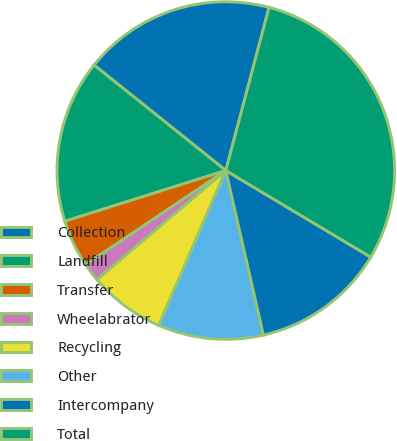Convert chart to OTSL. <chart><loc_0><loc_0><loc_500><loc_500><pie_chart><fcel>Collection<fcel>Landfill<fcel>Transfer<fcel>Wheelabrator<fcel>Recycling<fcel>Other<fcel>Intercompany<fcel>Total<nl><fcel>18.38%<fcel>15.61%<fcel>4.55%<fcel>1.78%<fcel>7.31%<fcel>10.08%<fcel>12.85%<fcel>29.45%<nl></chart> 